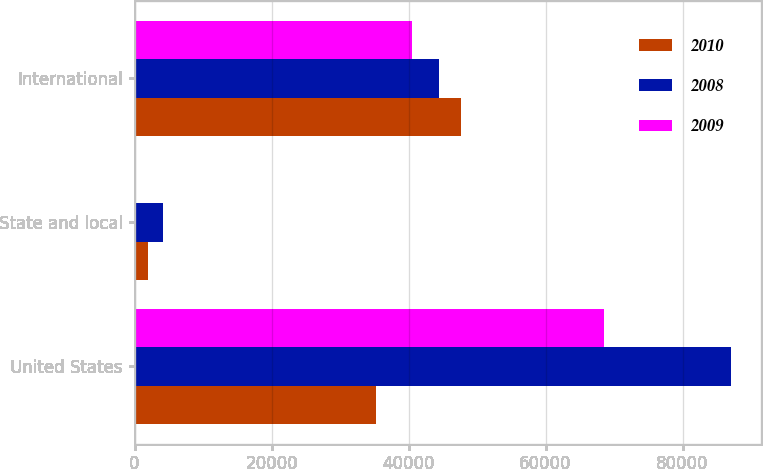Convert chart. <chart><loc_0><loc_0><loc_500><loc_500><stacked_bar_chart><ecel><fcel>United States<fcel>State and local<fcel>International<nl><fcel>2010<fcel>35232<fcel>1931<fcel>47633<nl><fcel>2008<fcel>87053<fcel>4142<fcel>44436<nl><fcel>2009<fcel>68514<fcel>251<fcel>40530<nl></chart> 